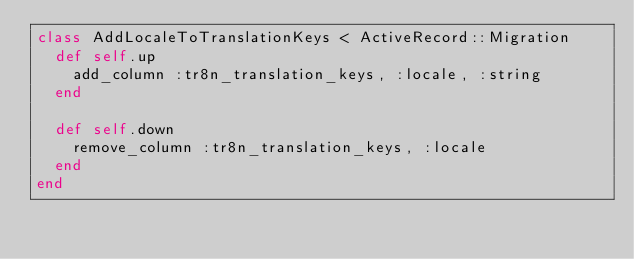Convert code to text. <code><loc_0><loc_0><loc_500><loc_500><_Ruby_>class AddLocaleToTranslationKeys < ActiveRecord::Migration
  def self.up
    add_column :tr8n_translation_keys, :locale, :string
  end

  def self.down
    remove_column :tr8n_translation_keys, :locale
  end
end
</code> 